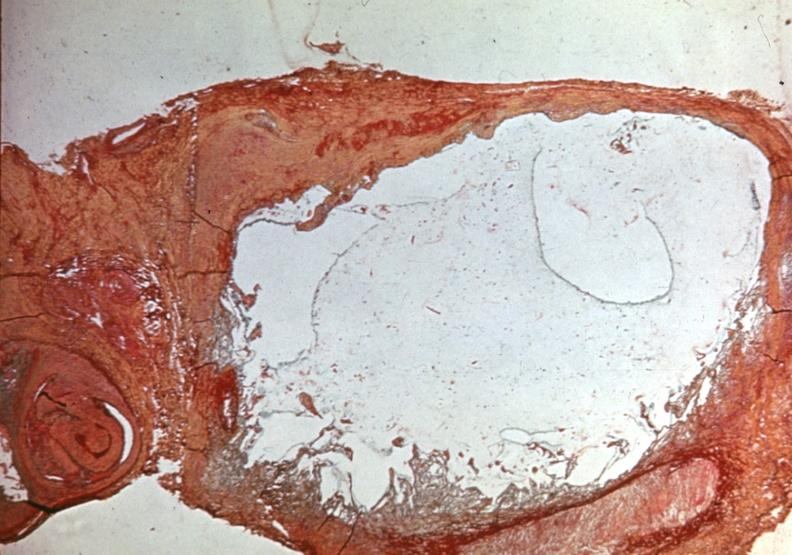what does this image show?
Answer the question using a single word or phrase. Popliteal cyst myxoid 